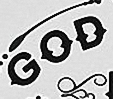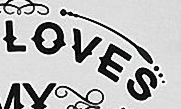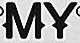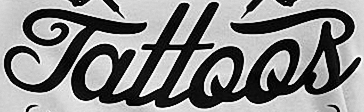What words are shown in these images in order, separated by a semicolon? GOD; LOVES; MY; Tattoos 